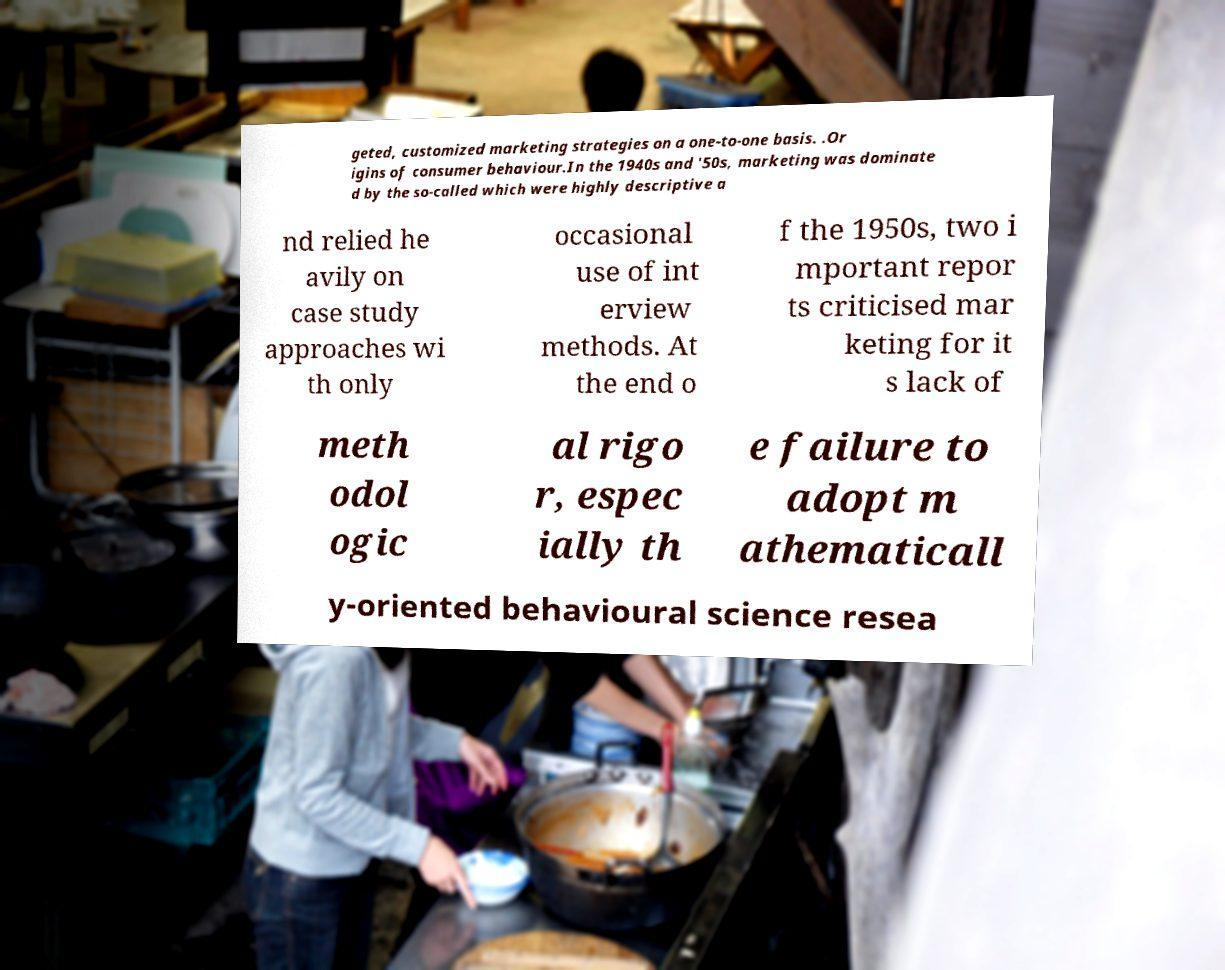What messages or text are displayed in this image? I need them in a readable, typed format. geted, customized marketing strategies on a one-to-one basis. .Or igins of consumer behaviour.In the 1940s and '50s, marketing was dominate d by the so-called which were highly descriptive a nd relied he avily on case study approaches wi th only occasional use of int erview methods. At the end o f the 1950s, two i mportant repor ts criticised mar keting for it s lack of meth odol ogic al rigo r, espec ially th e failure to adopt m athematicall y-oriented behavioural science resea 